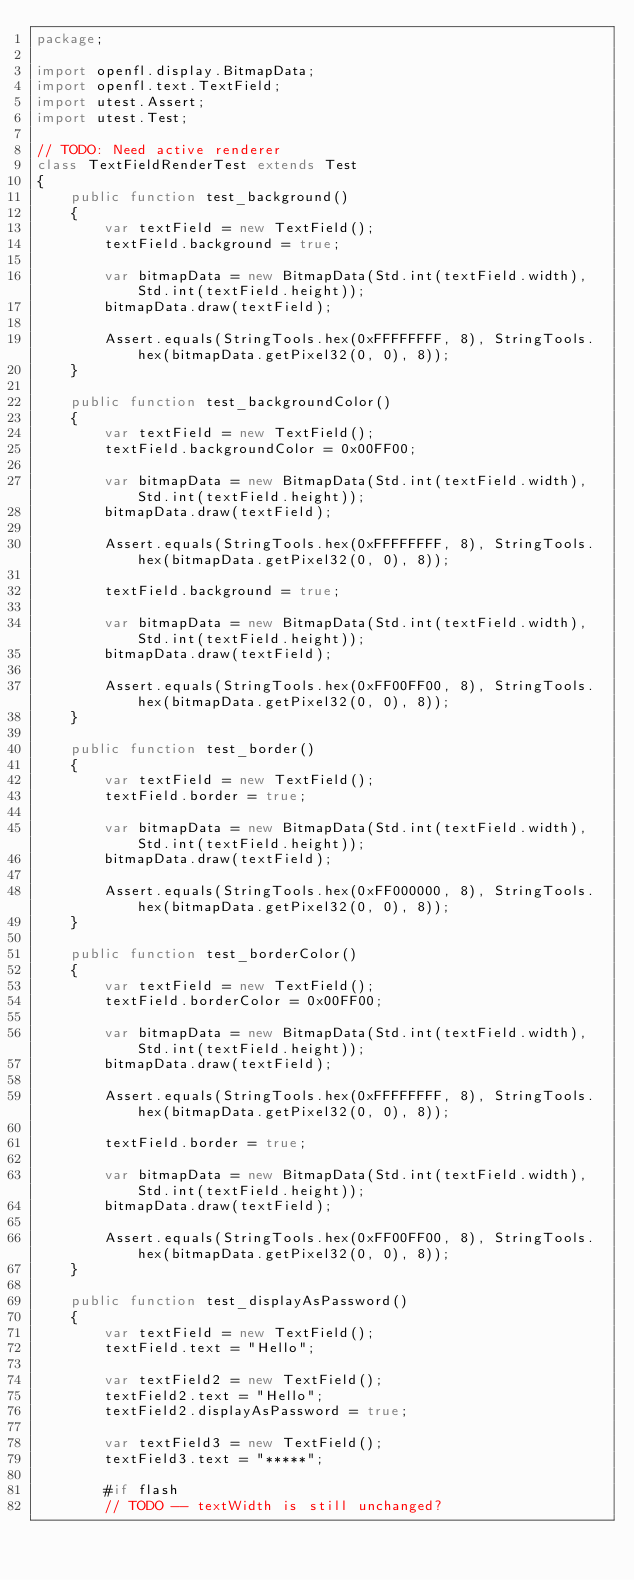<code> <loc_0><loc_0><loc_500><loc_500><_Haxe_>package;

import openfl.display.BitmapData;
import openfl.text.TextField;
import utest.Assert;
import utest.Test;

// TODO: Need active renderer
class TextFieldRenderTest extends Test
{
	public function test_background()
	{
		var textField = new TextField();
		textField.background = true;

		var bitmapData = new BitmapData(Std.int(textField.width), Std.int(textField.height));
		bitmapData.draw(textField);

		Assert.equals(StringTools.hex(0xFFFFFFFF, 8), StringTools.hex(bitmapData.getPixel32(0, 0), 8));
	}

	public function test_backgroundColor()
	{
		var textField = new TextField();
		textField.backgroundColor = 0x00FF00;

		var bitmapData = new BitmapData(Std.int(textField.width), Std.int(textField.height));
		bitmapData.draw(textField);

		Assert.equals(StringTools.hex(0xFFFFFFFF, 8), StringTools.hex(bitmapData.getPixel32(0, 0), 8));

		textField.background = true;

		var bitmapData = new BitmapData(Std.int(textField.width), Std.int(textField.height));
		bitmapData.draw(textField);

		Assert.equals(StringTools.hex(0xFF00FF00, 8), StringTools.hex(bitmapData.getPixel32(0, 0), 8));
	}

	public function test_border()
	{
		var textField = new TextField();
		textField.border = true;

		var bitmapData = new BitmapData(Std.int(textField.width), Std.int(textField.height));
		bitmapData.draw(textField);

		Assert.equals(StringTools.hex(0xFF000000, 8), StringTools.hex(bitmapData.getPixel32(0, 0), 8));
	}

	public function test_borderColor()
	{
		var textField = new TextField();
		textField.borderColor = 0x00FF00;

		var bitmapData = new BitmapData(Std.int(textField.width), Std.int(textField.height));
		bitmapData.draw(textField);

		Assert.equals(StringTools.hex(0xFFFFFFFF, 8), StringTools.hex(bitmapData.getPixel32(0, 0), 8));

		textField.border = true;

		var bitmapData = new BitmapData(Std.int(textField.width), Std.int(textField.height));
		bitmapData.draw(textField);

		Assert.equals(StringTools.hex(0xFF00FF00, 8), StringTools.hex(bitmapData.getPixel32(0, 0), 8));
	}

	public function test_displayAsPassword()
	{
		var textField = new TextField();
		textField.text = "Hello";

		var textField2 = new TextField();
		textField2.text = "Hello";
		textField2.displayAsPassword = true;

		var textField3 = new TextField();
		textField3.text = "*****";

		#if flash
		// TODO -- textWidth is still unchanged?</code> 